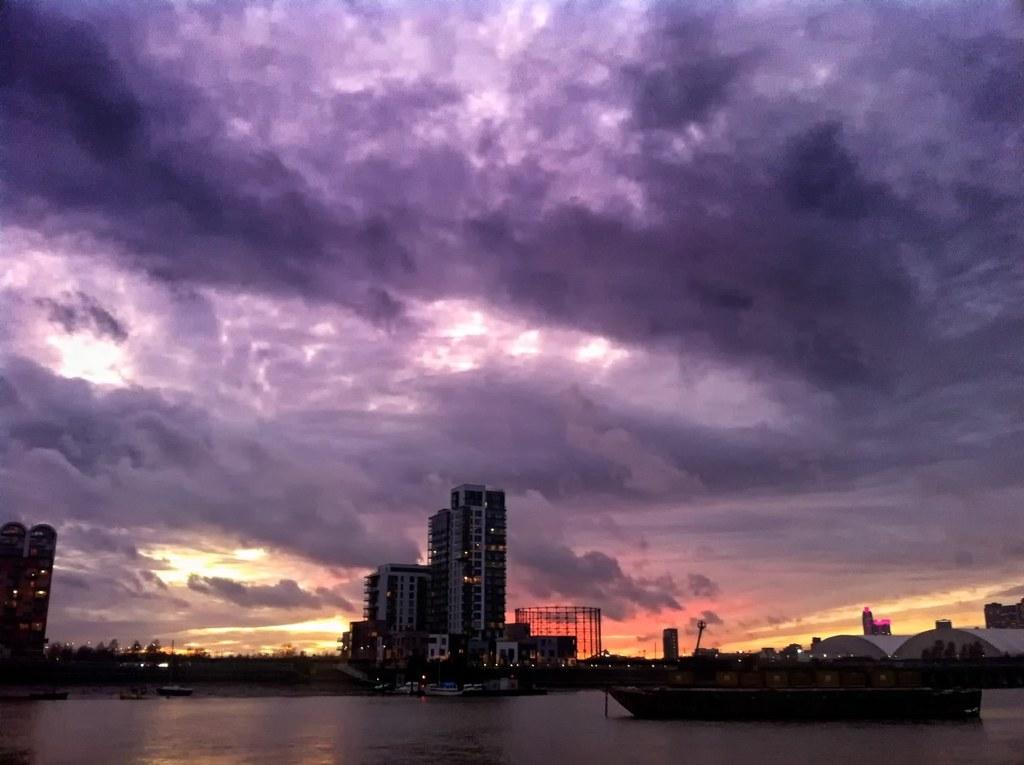What type of natural feature can be seen in the image? There is a river in the image. What man-made structures are present in the image? There are buildings in the image. What type of vegetation is visible on the ground in the image? There are trees on the ground in the image. What are the poles used for in the image? The poles are likely used for supporting lights or other structures in the image. What type of transportation can be seen on the river in the image? There are boats on the river in the image. How would you describe the sky in the image? The sky is colorful and cloudy in the image. What type of patch is visible on the river in the image? There is no patch visible on the river in the image. What direction is the mass moving in the image? There is no mass or movement of any object in the image that would allow us to determine a direction. 